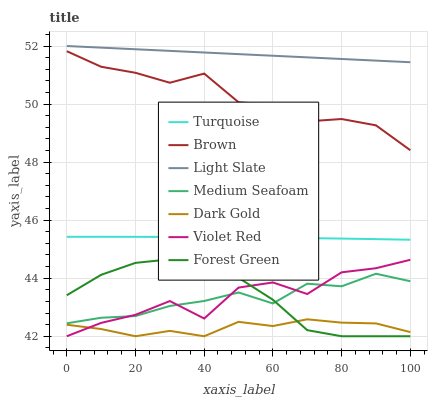Does Dark Gold have the minimum area under the curve?
Answer yes or no. Yes. Does Light Slate have the maximum area under the curve?
Answer yes or no. Yes. Does Turquoise have the minimum area under the curve?
Answer yes or no. No. Does Turquoise have the maximum area under the curve?
Answer yes or no. No. Is Light Slate the smoothest?
Answer yes or no. Yes. Is Violet Red the roughest?
Answer yes or no. Yes. Is Turquoise the smoothest?
Answer yes or no. No. Is Turquoise the roughest?
Answer yes or no. No. Does Dark Gold have the lowest value?
Answer yes or no. Yes. Does Turquoise have the lowest value?
Answer yes or no. No. Does Light Slate have the highest value?
Answer yes or no. Yes. Does Turquoise have the highest value?
Answer yes or no. No. Is Forest Green less than Turquoise?
Answer yes or no. Yes. Is Light Slate greater than Forest Green?
Answer yes or no. Yes. Does Dark Gold intersect Forest Green?
Answer yes or no. Yes. Is Dark Gold less than Forest Green?
Answer yes or no. No. Is Dark Gold greater than Forest Green?
Answer yes or no. No. Does Forest Green intersect Turquoise?
Answer yes or no. No. 